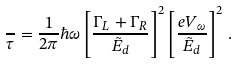<formula> <loc_0><loc_0><loc_500><loc_500>\frac { } { \tau } = \frac { 1 } { 2 \pi } \hbar { \omega } \left [ \frac { \Gamma _ { L } + \Gamma _ { R } } { \tilde { E } _ { d } } \right ] ^ { 2 } \left [ \frac { e V _ { \omega } } { \tilde { E } _ { d } } \right ] ^ { 2 } \, .</formula> 